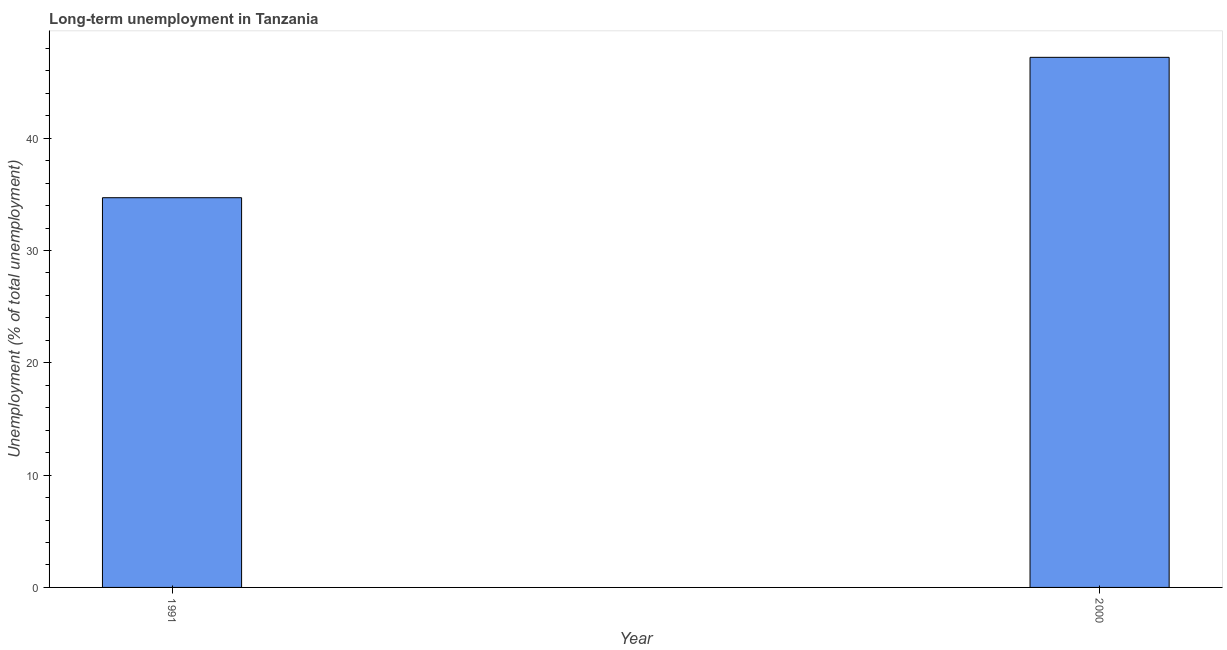Does the graph contain any zero values?
Make the answer very short. No. What is the title of the graph?
Ensure brevity in your answer.  Long-term unemployment in Tanzania. What is the label or title of the X-axis?
Give a very brief answer. Year. What is the label or title of the Y-axis?
Your response must be concise. Unemployment (% of total unemployment). What is the long-term unemployment in 1991?
Make the answer very short. 34.7. Across all years, what is the maximum long-term unemployment?
Your response must be concise. 47.2. Across all years, what is the minimum long-term unemployment?
Your response must be concise. 34.7. In which year was the long-term unemployment maximum?
Offer a terse response. 2000. In which year was the long-term unemployment minimum?
Ensure brevity in your answer.  1991. What is the sum of the long-term unemployment?
Provide a succinct answer. 81.9. What is the average long-term unemployment per year?
Give a very brief answer. 40.95. What is the median long-term unemployment?
Give a very brief answer. 40.95. What is the ratio of the long-term unemployment in 1991 to that in 2000?
Offer a terse response. 0.73. What is the Unemployment (% of total unemployment) in 1991?
Your response must be concise. 34.7. What is the Unemployment (% of total unemployment) of 2000?
Your answer should be very brief. 47.2. What is the difference between the Unemployment (% of total unemployment) in 1991 and 2000?
Your answer should be compact. -12.5. What is the ratio of the Unemployment (% of total unemployment) in 1991 to that in 2000?
Give a very brief answer. 0.73. 